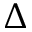<formula> <loc_0><loc_0><loc_500><loc_500>\Delta</formula> 